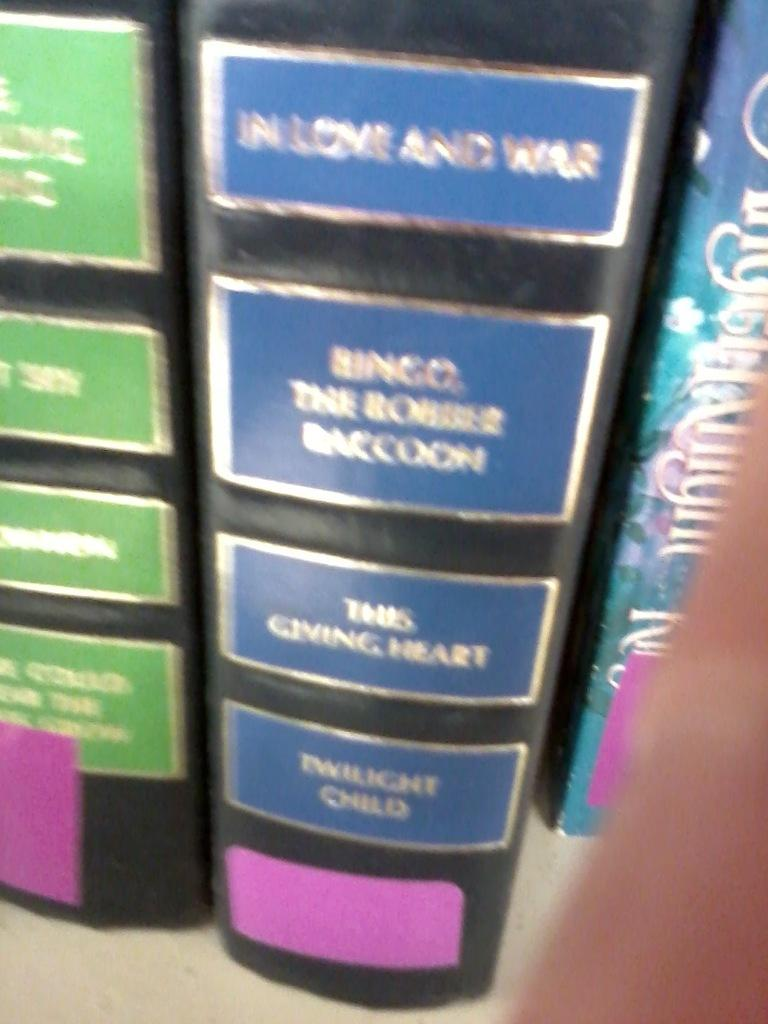What type of objects can be seen in the image? There are books in the image. Can you describe the appearance of the books? The books appear to be bound with covers and pages. How many books are visible in the image? The number of books cannot be determined from the provided facts. What type of opinion can be seen expressed by the pencil in the image? There is no pencil present in the image, and therefore no opinion can be expressed by a pencil. 